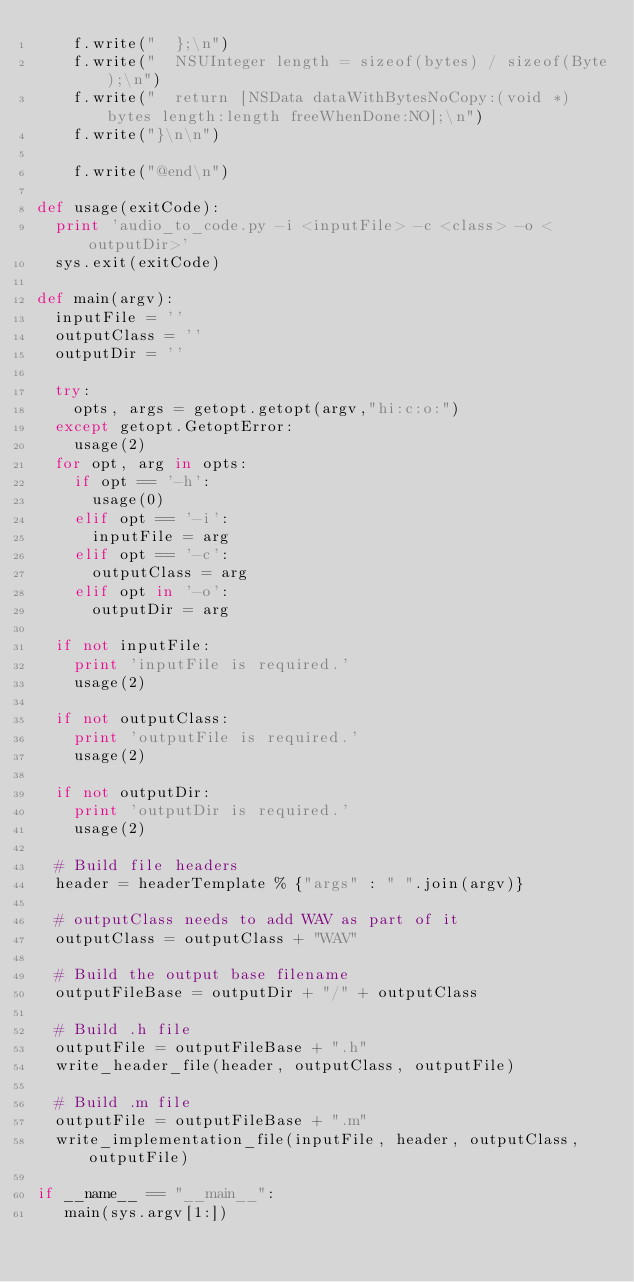<code> <loc_0><loc_0><loc_500><loc_500><_Python_>    f.write("  };\n")
    f.write("  NSUInteger length = sizeof(bytes) / sizeof(Byte);\n")
    f.write("  return [NSData dataWithBytesNoCopy:(void *)bytes length:length freeWhenDone:NO];\n")
    f.write("}\n\n")

    f.write("@end\n")

def usage(exitCode):
  print 'audio_to_code.py -i <inputFile> -c <class> -o <outputDir>'
  sys.exit(exitCode)

def main(argv):
  inputFile = ''
  outputClass = ''
  outputDir = ''

  try:
    opts, args = getopt.getopt(argv,"hi:c:o:")
  except getopt.GetoptError:
    usage(2)
  for opt, arg in opts:
    if opt == '-h':
      usage(0)
    elif opt == '-i':
      inputFile = arg
    elif opt == '-c':
      outputClass = arg
    elif opt in '-o':
      outputDir = arg

  if not inputFile:
    print 'inputFile is required.'
    usage(2)

  if not outputClass:
    print 'outputFile is required.'
    usage(2)

  if not outputDir:
    print 'outputDir is required.'
    usage(2)

  # Build file headers
  header = headerTemplate % {"args" : " ".join(argv)}

  # outputClass needs to add WAV as part of it
  outputClass = outputClass + "WAV"

  # Build the output base filename
  outputFileBase = outputDir + "/" + outputClass

  # Build .h file
  outputFile = outputFileBase + ".h"
  write_header_file(header, outputClass, outputFile)

  # Build .m file
  outputFile = outputFileBase + ".m"
  write_implementation_file(inputFile, header, outputClass, outputFile)

if __name__ == "__main__":
   main(sys.argv[1:])
</code> 